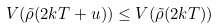Convert formula to latex. <formula><loc_0><loc_0><loc_500><loc_500>V ( \tilde { \rho } ( 2 k T + u ) ) \leq V ( \tilde { \rho } ( 2 k T ) )</formula> 